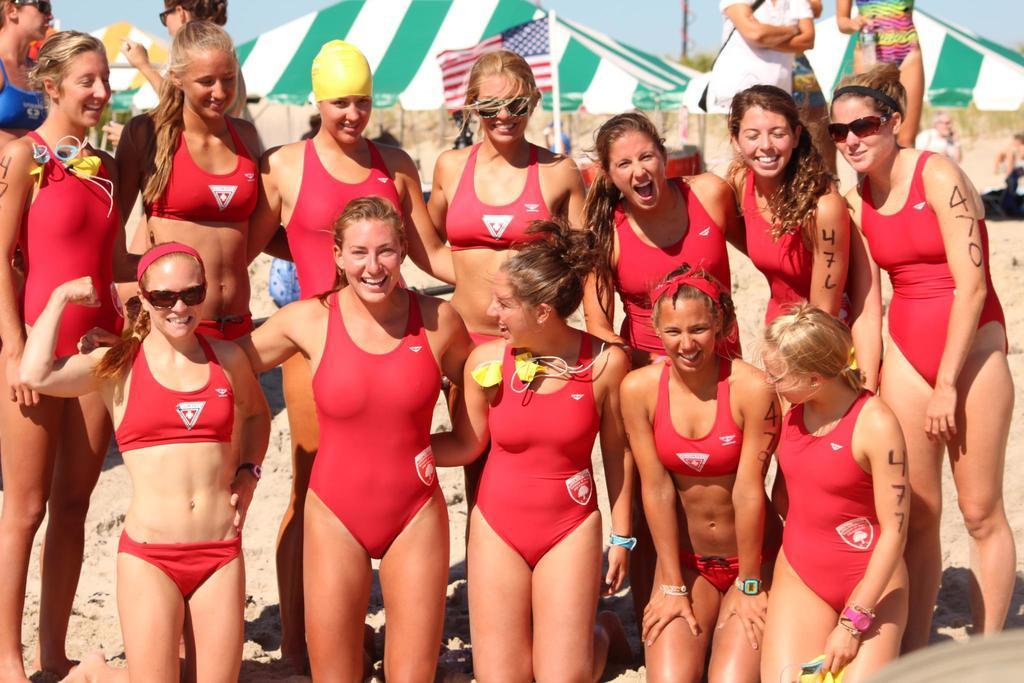Describe this image in one or two sentences. In this image I can see number of women and I can see all of them are wearing red colour dress. I can also see smile on their faces and in the background I can see few more people, a flag and the sky. I can also see something in the background which looks like tent houses. 